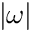<formula> <loc_0><loc_0><loc_500><loc_500>| \omega |</formula> 